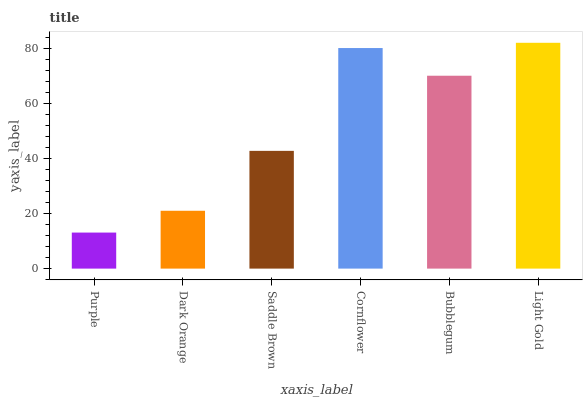Is Purple the minimum?
Answer yes or no. Yes. Is Light Gold the maximum?
Answer yes or no. Yes. Is Dark Orange the minimum?
Answer yes or no. No. Is Dark Orange the maximum?
Answer yes or no. No. Is Dark Orange greater than Purple?
Answer yes or no. Yes. Is Purple less than Dark Orange?
Answer yes or no. Yes. Is Purple greater than Dark Orange?
Answer yes or no. No. Is Dark Orange less than Purple?
Answer yes or no. No. Is Bubblegum the high median?
Answer yes or no. Yes. Is Saddle Brown the low median?
Answer yes or no. Yes. Is Dark Orange the high median?
Answer yes or no. No. Is Bubblegum the low median?
Answer yes or no. No. 